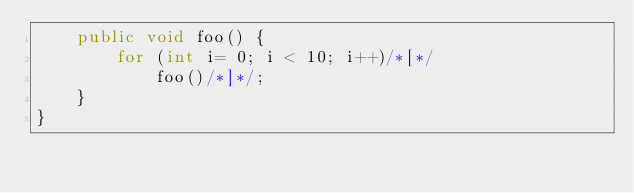Convert code to text. <code><loc_0><loc_0><loc_500><loc_500><_Java_>	public void foo() {
		for (int i= 0; i < 10; i++)/*[*/
			foo()/*]*/;
	}	
}</code> 